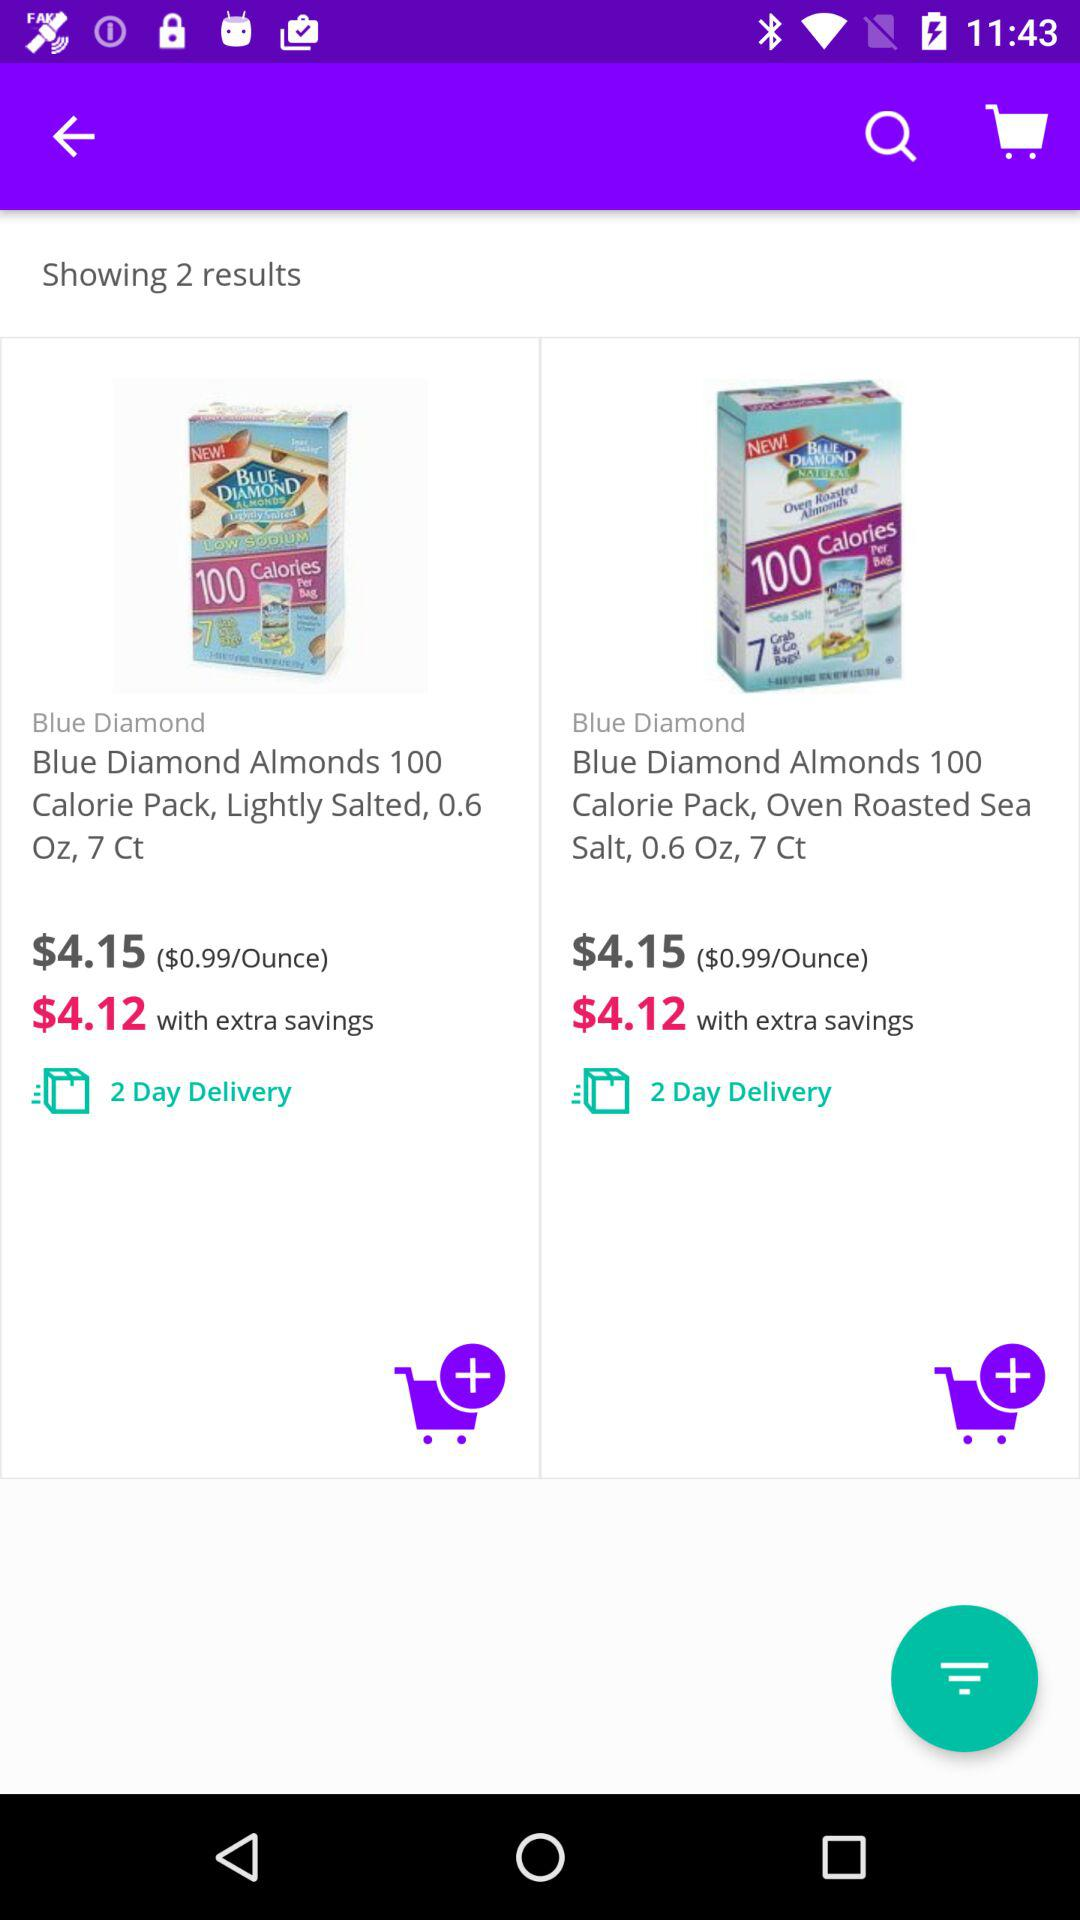Are there any special deals for the items in the image? Yes, both items shown in the image have a special deal that offers extra savings, bringing the price down from $4.15 to $4.12 each. This small discount is highlighted in green, indicating a promotion or a temporary special offer. 